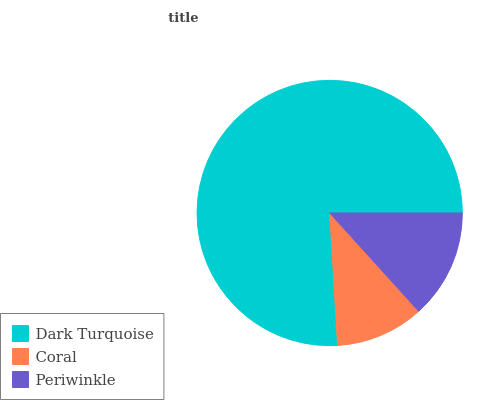Is Coral the minimum?
Answer yes or no. Yes. Is Dark Turquoise the maximum?
Answer yes or no. Yes. Is Periwinkle the minimum?
Answer yes or no. No. Is Periwinkle the maximum?
Answer yes or no. No. Is Periwinkle greater than Coral?
Answer yes or no. Yes. Is Coral less than Periwinkle?
Answer yes or no. Yes. Is Coral greater than Periwinkle?
Answer yes or no. No. Is Periwinkle less than Coral?
Answer yes or no. No. Is Periwinkle the high median?
Answer yes or no. Yes. Is Periwinkle the low median?
Answer yes or no. Yes. Is Dark Turquoise the high median?
Answer yes or no. No. Is Dark Turquoise the low median?
Answer yes or no. No. 